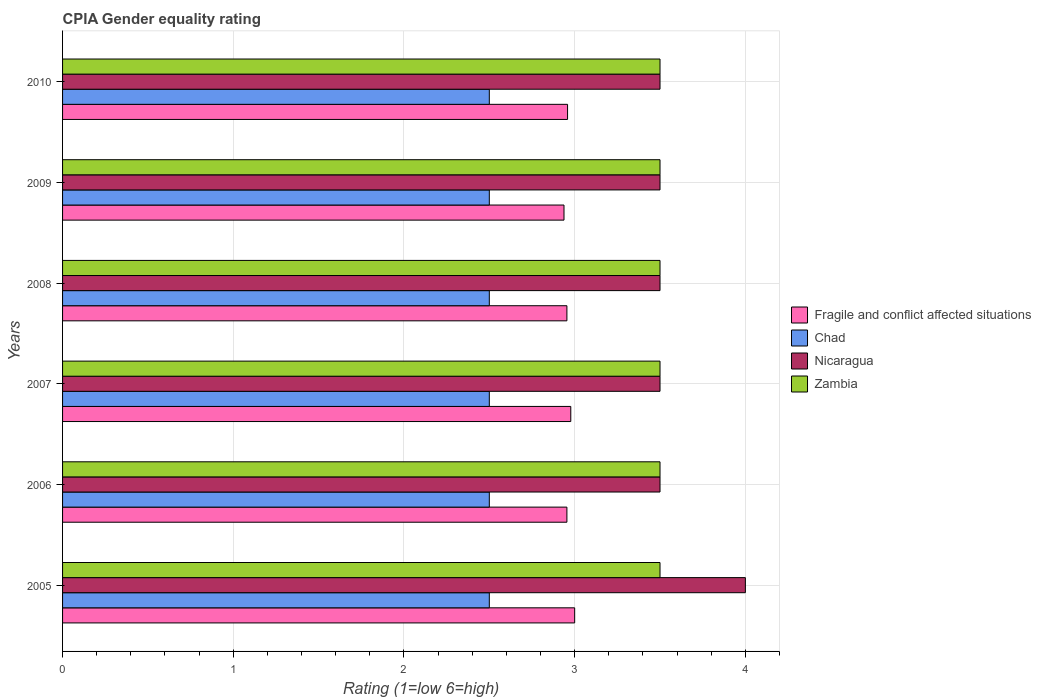Are the number of bars per tick equal to the number of legend labels?
Ensure brevity in your answer.  Yes. How many bars are there on the 6th tick from the top?
Provide a succinct answer. 4. What is the CPIA rating in Chad in 2005?
Offer a terse response. 2.5. In which year was the CPIA rating in Chad maximum?
Offer a very short reply. 2005. In which year was the CPIA rating in Chad minimum?
Give a very brief answer. 2005. What is the difference between the CPIA rating in Fragile and conflict affected situations in 2008 and that in 2009?
Provide a succinct answer. 0.02. What is the average CPIA rating in Nicaragua per year?
Give a very brief answer. 3.58. What is the ratio of the CPIA rating in Nicaragua in 2005 to that in 2008?
Your answer should be very brief. 1.14. Is the sum of the CPIA rating in Fragile and conflict affected situations in 2007 and 2008 greater than the maximum CPIA rating in Zambia across all years?
Ensure brevity in your answer.  Yes. What does the 3rd bar from the top in 2008 represents?
Provide a succinct answer. Chad. What does the 2nd bar from the bottom in 2010 represents?
Offer a terse response. Chad. Are all the bars in the graph horizontal?
Ensure brevity in your answer.  Yes. How many years are there in the graph?
Provide a succinct answer. 6. Does the graph contain grids?
Make the answer very short. Yes. How many legend labels are there?
Keep it short and to the point. 4. What is the title of the graph?
Make the answer very short. CPIA Gender equality rating. What is the label or title of the X-axis?
Your response must be concise. Rating (1=low 6=high). What is the Rating (1=low 6=high) of Nicaragua in 2005?
Your answer should be compact. 4. What is the Rating (1=low 6=high) in Zambia in 2005?
Provide a succinct answer. 3.5. What is the Rating (1=low 6=high) of Fragile and conflict affected situations in 2006?
Your response must be concise. 2.95. What is the Rating (1=low 6=high) of Chad in 2006?
Provide a succinct answer. 2.5. What is the Rating (1=low 6=high) of Nicaragua in 2006?
Your response must be concise. 3.5. What is the Rating (1=low 6=high) in Zambia in 2006?
Your response must be concise. 3.5. What is the Rating (1=low 6=high) of Fragile and conflict affected situations in 2007?
Offer a terse response. 2.98. What is the Rating (1=low 6=high) in Chad in 2007?
Your response must be concise. 2.5. What is the Rating (1=low 6=high) of Zambia in 2007?
Give a very brief answer. 3.5. What is the Rating (1=low 6=high) of Fragile and conflict affected situations in 2008?
Keep it short and to the point. 2.95. What is the Rating (1=low 6=high) of Chad in 2008?
Make the answer very short. 2.5. What is the Rating (1=low 6=high) of Fragile and conflict affected situations in 2009?
Offer a very short reply. 2.94. What is the Rating (1=low 6=high) in Fragile and conflict affected situations in 2010?
Your answer should be very brief. 2.96. Across all years, what is the maximum Rating (1=low 6=high) of Zambia?
Offer a terse response. 3.5. Across all years, what is the minimum Rating (1=low 6=high) in Fragile and conflict affected situations?
Provide a succinct answer. 2.94. Across all years, what is the minimum Rating (1=low 6=high) of Chad?
Provide a short and direct response. 2.5. What is the total Rating (1=low 6=high) in Fragile and conflict affected situations in the graph?
Offer a terse response. 17.78. What is the total Rating (1=low 6=high) in Chad in the graph?
Offer a very short reply. 15. What is the total Rating (1=low 6=high) of Nicaragua in the graph?
Provide a succinct answer. 21.5. What is the total Rating (1=low 6=high) of Zambia in the graph?
Make the answer very short. 21. What is the difference between the Rating (1=low 6=high) of Fragile and conflict affected situations in 2005 and that in 2006?
Give a very brief answer. 0.05. What is the difference between the Rating (1=low 6=high) of Fragile and conflict affected situations in 2005 and that in 2007?
Provide a succinct answer. 0.02. What is the difference between the Rating (1=low 6=high) of Fragile and conflict affected situations in 2005 and that in 2008?
Make the answer very short. 0.05. What is the difference between the Rating (1=low 6=high) of Nicaragua in 2005 and that in 2008?
Offer a very short reply. 0.5. What is the difference between the Rating (1=low 6=high) of Fragile and conflict affected situations in 2005 and that in 2009?
Offer a very short reply. 0.06. What is the difference between the Rating (1=low 6=high) in Nicaragua in 2005 and that in 2009?
Ensure brevity in your answer.  0.5. What is the difference between the Rating (1=low 6=high) in Fragile and conflict affected situations in 2005 and that in 2010?
Make the answer very short. 0.04. What is the difference between the Rating (1=low 6=high) of Fragile and conflict affected situations in 2006 and that in 2007?
Offer a terse response. -0.02. What is the difference between the Rating (1=low 6=high) of Zambia in 2006 and that in 2007?
Give a very brief answer. 0. What is the difference between the Rating (1=low 6=high) in Fragile and conflict affected situations in 2006 and that in 2008?
Your answer should be compact. 0. What is the difference between the Rating (1=low 6=high) in Fragile and conflict affected situations in 2006 and that in 2009?
Ensure brevity in your answer.  0.02. What is the difference between the Rating (1=low 6=high) of Chad in 2006 and that in 2009?
Provide a succinct answer. 0. What is the difference between the Rating (1=low 6=high) of Nicaragua in 2006 and that in 2009?
Ensure brevity in your answer.  0. What is the difference between the Rating (1=low 6=high) in Zambia in 2006 and that in 2009?
Keep it short and to the point. 0. What is the difference between the Rating (1=low 6=high) in Fragile and conflict affected situations in 2006 and that in 2010?
Your answer should be very brief. -0. What is the difference between the Rating (1=low 6=high) of Chad in 2006 and that in 2010?
Provide a short and direct response. 0. What is the difference between the Rating (1=low 6=high) of Nicaragua in 2006 and that in 2010?
Provide a short and direct response. 0. What is the difference between the Rating (1=low 6=high) of Zambia in 2006 and that in 2010?
Give a very brief answer. 0. What is the difference between the Rating (1=low 6=high) of Fragile and conflict affected situations in 2007 and that in 2008?
Offer a terse response. 0.02. What is the difference between the Rating (1=low 6=high) in Nicaragua in 2007 and that in 2008?
Ensure brevity in your answer.  0. What is the difference between the Rating (1=low 6=high) in Fragile and conflict affected situations in 2007 and that in 2009?
Offer a terse response. 0.04. What is the difference between the Rating (1=low 6=high) in Chad in 2007 and that in 2009?
Ensure brevity in your answer.  0. What is the difference between the Rating (1=low 6=high) of Zambia in 2007 and that in 2009?
Keep it short and to the point. 0. What is the difference between the Rating (1=low 6=high) in Fragile and conflict affected situations in 2007 and that in 2010?
Your answer should be compact. 0.02. What is the difference between the Rating (1=low 6=high) in Nicaragua in 2007 and that in 2010?
Offer a terse response. 0. What is the difference between the Rating (1=low 6=high) of Zambia in 2007 and that in 2010?
Your answer should be very brief. 0. What is the difference between the Rating (1=low 6=high) in Fragile and conflict affected situations in 2008 and that in 2009?
Provide a succinct answer. 0.02. What is the difference between the Rating (1=low 6=high) of Chad in 2008 and that in 2009?
Your answer should be compact. 0. What is the difference between the Rating (1=low 6=high) in Fragile and conflict affected situations in 2008 and that in 2010?
Keep it short and to the point. -0. What is the difference between the Rating (1=low 6=high) of Fragile and conflict affected situations in 2009 and that in 2010?
Your response must be concise. -0.02. What is the difference between the Rating (1=low 6=high) in Nicaragua in 2009 and that in 2010?
Your response must be concise. 0. What is the difference between the Rating (1=low 6=high) in Fragile and conflict affected situations in 2005 and the Rating (1=low 6=high) in Nicaragua in 2006?
Your response must be concise. -0.5. What is the difference between the Rating (1=low 6=high) of Chad in 2005 and the Rating (1=low 6=high) of Nicaragua in 2006?
Offer a very short reply. -1. What is the difference between the Rating (1=low 6=high) of Chad in 2005 and the Rating (1=low 6=high) of Zambia in 2006?
Provide a succinct answer. -1. What is the difference between the Rating (1=low 6=high) of Nicaragua in 2005 and the Rating (1=low 6=high) of Zambia in 2006?
Your answer should be compact. 0.5. What is the difference between the Rating (1=low 6=high) in Chad in 2005 and the Rating (1=low 6=high) in Nicaragua in 2007?
Provide a short and direct response. -1. What is the difference between the Rating (1=low 6=high) in Nicaragua in 2005 and the Rating (1=low 6=high) in Zambia in 2007?
Offer a very short reply. 0.5. What is the difference between the Rating (1=low 6=high) in Fragile and conflict affected situations in 2005 and the Rating (1=low 6=high) in Chad in 2008?
Your answer should be compact. 0.5. What is the difference between the Rating (1=low 6=high) of Fragile and conflict affected situations in 2005 and the Rating (1=low 6=high) of Zambia in 2008?
Give a very brief answer. -0.5. What is the difference between the Rating (1=low 6=high) in Chad in 2005 and the Rating (1=low 6=high) in Nicaragua in 2008?
Offer a very short reply. -1. What is the difference between the Rating (1=low 6=high) in Nicaragua in 2005 and the Rating (1=low 6=high) in Zambia in 2008?
Your answer should be very brief. 0.5. What is the difference between the Rating (1=low 6=high) in Fragile and conflict affected situations in 2005 and the Rating (1=low 6=high) in Zambia in 2009?
Your answer should be very brief. -0.5. What is the difference between the Rating (1=low 6=high) in Chad in 2005 and the Rating (1=low 6=high) in Nicaragua in 2009?
Provide a short and direct response. -1. What is the difference between the Rating (1=low 6=high) in Fragile and conflict affected situations in 2005 and the Rating (1=low 6=high) in Nicaragua in 2010?
Make the answer very short. -0.5. What is the difference between the Rating (1=low 6=high) of Fragile and conflict affected situations in 2005 and the Rating (1=low 6=high) of Zambia in 2010?
Provide a succinct answer. -0.5. What is the difference between the Rating (1=low 6=high) in Chad in 2005 and the Rating (1=low 6=high) in Nicaragua in 2010?
Ensure brevity in your answer.  -1. What is the difference between the Rating (1=low 6=high) in Fragile and conflict affected situations in 2006 and the Rating (1=low 6=high) in Chad in 2007?
Make the answer very short. 0.45. What is the difference between the Rating (1=low 6=high) of Fragile and conflict affected situations in 2006 and the Rating (1=low 6=high) of Nicaragua in 2007?
Offer a very short reply. -0.55. What is the difference between the Rating (1=low 6=high) in Fragile and conflict affected situations in 2006 and the Rating (1=low 6=high) in Zambia in 2007?
Provide a succinct answer. -0.55. What is the difference between the Rating (1=low 6=high) in Fragile and conflict affected situations in 2006 and the Rating (1=low 6=high) in Chad in 2008?
Your answer should be compact. 0.45. What is the difference between the Rating (1=low 6=high) in Fragile and conflict affected situations in 2006 and the Rating (1=low 6=high) in Nicaragua in 2008?
Give a very brief answer. -0.55. What is the difference between the Rating (1=low 6=high) in Fragile and conflict affected situations in 2006 and the Rating (1=low 6=high) in Zambia in 2008?
Provide a short and direct response. -0.55. What is the difference between the Rating (1=low 6=high) in Chad in 2006 and the Rating (1=low 6=high) in Zambia in 2008?
Your answer should be compact. -1. What is the difference between the Rating (1=low 6=high) of Fragile and conflict affected situations in 2006 and the Rating (1=low 6=high) of Chad in 2009?
Make the answer very short. 0.45. What is the difference between the Rating (1=low 6=high) in Fragile and conflict affected situations in 2006 and the Rating (1=low 6=high) in Nicaragua in 2009?
Offer a very short reply. -0.55. What is the difference between the Rating (1=low 6=high) in Fragile and conflict affected situations in 2006 and the Rating (1=low 6=high) in Zambia in 2009?
Your answer should be very brief. -0.55. What is the difference between the Rating (1=low 6=high) of Nicaragua in 2006 and the Rating (1=low 6=high) of Zambia in 2009?
Provide a succinct answer. 0. What is the difference between the Rating (1=low 6=high) in Fragile and conflict affected situations in 2006 and the Rating (1=low 6=high) in Chad in 2010?
Your answer should be very brief. 0.45. What is the difference between the Rating (1=low 6=high) of Fragile and conflict affected situations in 2006 and the Rating (1=low 6=high) of Nicaragua in 2010?
Your answer should be very brief. -0.55. What is the difference between the Rating (1=low 6=high) of Fragile and conflict affected situations in 2006 and the Rating (1=low 6=high) of Zambia in 2010?
Provide a short and direct response. -0.55. What is the difference between the Rating (1=low 6=high) in Chad in 2006 and the Rating (1=low 6=high) in Nicaragua in 2010?
Your answer should be very brief. -1. What is the difference between the Rating (1=low 6=high) in Nicaragua in 2006 and the Rating (1=low 6=high) in Zambia in 2010?
Offer a very short reply. 0. What is the difference between the Rating (1=low 6=high) of Fragile and conflict affected situations in 2007 and the Rating (1=low 6=high) of Chad in 2008?
Offer a very short reply. 0.48. What is the difference between the Rating (1=low 6=high) of Fragile and conflict affected situations in 2007 and the Rating (1=low 6=high) of Nicaragua in 2008?
Your answer should be compact. -0.52. What is the difference between the Rating (1=low 6=high) in Fragile and conflict affected situations in 2007 and the Rating (1=low 6=high) in Zambia in 2008?
Offer a terse response. -0.52. What is the difference between the Rating (1=low 6=high) of Chad in 2007 and the Rating (1=low 6=high) of Nicaragua in 2008?
Provide a short and direct response. -1. What is the difference between the Rating (1=low 6=high) in Fragile and conflict affected situations in 2007 and the Rating (1=low 6=high) in Chad in 2009?
Your answer should be very brief. 0.48. What is the difference between the Rating (1=low 6=high) of Fragile and conflict affected situations in 2007 and the Rating (1=low 6=high) of Nicaragua in 2009?
Your answer should be very brief. -0.52. What is the difference between the Rating (1=low 6=high) of Fragile and conflict affected situations in 2007 and the Rating (1=low 6=high) of Zambia in 2009?
Offer a very short reply. -0.52. What is the difference between the Rating (1=low 6=high) in Chad in 2007 and the Rating (1=low 6=high) in Nicaragua in 2009?
Your response must be concise. -1. What is the difference between the Rating (1=low 6=high) of Fragile and conflict affected situations in 2007 and the Rating (1=low 6=high) of Chad in 2010?
Your answer should be very brief. 0.48. What is the difference between the Rating (1=low 6=high) in Fragile and conflict affected situations in 2007 and the Rating (1=low 6=high) in Nicaragua in 2010?
Provide a short and direct response. -0.52. What is the difference between the Rating (1=low 6=high) in Fragile and conflict affected situations in 2007 and the Rating (1=low 6=high) in Zambia in 2010?
Your answer should be compact. -0.52. What is the difference between the Rating (1=low 6=high) of Chad in 2007 and the Rating (1=low 6=high) of Nicaragua in 2010?
Your answer should be compact. -1. What is the difference between the Rating (1=low 6=high) of Chad in 2007 and the Rating (1=low 6=high) of Zambia in 2010?
Provide a succinct answer. -1. What is the difference between the Rating (1=low 6=high) of Nicaragua in 2007 and the Rating (1=low 6=high) of Zambia in 2010?
Your answer should be very brief. 0. What is the difference between the Rating (1=low 6=high) in Fragile and conflict affected situations in 2008 and the Rating (1=low 6=high) in Chad in 2009?
Provide a short and direct response. 0.45. What is the difference between the Rating (1=low 6=high) in Fragile and conflict affected situations in 2008 and the Rating (1=low 6=high) in Nicaragua in 2009?
Ensure brevity in your answer.  -0.55. What is the difference between the Rating (1=low 6=high) of Fragile and conflict affected situations in 2008 and the Rating (1=low 6=high) of Zambia in 2009?
Make the answer very short. -0.55. What is the difference between the Rating (1=low 6=high) in Chad in 2008 and the Rating (1=low 6=high) in Zambia in 2009?
Give a very brief answer. -1. What is the difference between the Rating (1=low 6=high) in Nicaragua in 2008 and the Rating (1=low 6=high) in Zambia in 2009?
Provide a succinct answer. 0. What is the difference between the Rating (1=low 6=high) in Fragile and conflict affected situations in 2008 and the Rating (1=low 6=high) in Chad in 2010?
Keep it short and to the point. 0.45. What is the difference between the Rating (1=low 6=high) in Fragile and conflict affected situations in 2008 and the Rating (1=low 6=high) in Nicaragua in 2010?
Offer a terse response. -0.55. What is the difference between the Rating (1=low 6=high) in Fragile and conflict affected situations in 2008 and the Rating (1=low 6=high) in Zambia in 2010?
Your answer should be compact. -0.55. What is the difference between the Rating (1=low 6=high) in Chad in 2008 and the Rating (1=low 6=high) in Nicaragua in 2010?
Keep it short and to the point. -1. What is the difference between the Rating (1=low 6=high) of Nicaragua in 2008 and the Rating (1=low 6=high) of Zambia in 2010?
Your answer should be very brief. 0. What is the difference between the Rating (1=low 6=high) of Fragile and conflict affected situations in 2009 and the Rating (1=low 6=high) of Chad in 2010?
Provide a short and direct response. 0.44. What is the difference between the Rating (1=low 6=high) in Fragile and conflict affected situations in 2009 and the Rating (1=low 6=high) in Nicaragua in 2010?
Offer a very short reply. -0.56. What is the difference between the Rating (1=low 6=high) in Fragile and conflict affected situations in 2009 and the Rating (1=low 6=high) in Zambia in 2010?
Offer a terse response. -0.56. What is the difference between the Rating (1=low 6=high) of Chad in 2009 and the Rating (1=low 6=high) of Nicaragua in 2010?
Your answer should be compact. -1. What is the difference between the Rating (1=low 6=high) in Chad in 2009 and the Rating (1=low 6=high) in Zambia in 2010?
Give a very brief answer. -1. What is the average Rating (1=low 6=high) of Fragile and conflict affected situations per year?
Offer a very short reply. 2.96. What is the average Rating (1=low 6=high) in Chad per year?
Your answer should be compact. 2.5. What is the average Rating (1=low 6=high) in Nicaragua per year?
Provide a short and direct response. 3.58. In the year 2005, what is the difference between the Rating (1=low 6=high) of Fragile and conflict affected situations and Rating (1=low 6=high) of Chad?
Ensure brevity in your answer.  0.5. In the year 2005, what is the difference between the Rating (1=low 6=high) in Nicaragua and Rating (1=low 6=high) in Zambia?
Provide a short and direct response. 0.5. In the year 2006, what is the difference between the Rating (1=low 6=high) of Fragile and conflict affected situations and Rating (1=low 6=high) of Chad?
Offer a terse response. 0.45. In the year 2006, what is the difference between the Rating (1=low 6=high) in Fragile and conflict affected situations and Rating (1=low 6=high) in Nicaragua?
Make the answer very short. -0.55. In the year 2006, what is the difference between the Rating (1=low 6=high) in Fragile and conflict affected situations and Rating (1=low 6=high) in Zambia?
Your response must be concise. -0.55. In the year 2006, what is the difference between the Rating (1=low 6=high) in Chad and Rating (1=low 6=high) in Zambia?
Your response must be concise. -1. In the year 2006, what is the difference between the Rating (1=low 6=high) of Nicaragua and Rating (1=low 6=high) of Zambia?
Offer a terse response. 0. In the year 2007, what is the difference between the Rating (1=low 6=high) of Fragile and conflict affected situations and Rating (1=low 6=high) of Chad?
Ensure brevity in your answer.  0.48. In the year 2007, what is the difference between the Rating (1=low 6=high) of Fragile and conflict affected situations and Rating (1=low 6=high) of Nicaragua?
Offer a terse response. -0.52. In the year 2007, what is the difference between the Rating (1=low 6=high) in Fragile and conflict affected situations and Rating (1=low 6=high) in Zambia?
Provide a short and direct response. -0.52. In the year 2007, what is the difference between the Rating (1=low 6=high) in Chad and Rating (1=low 6=high) in Nicaragua?
Ensure brevity in your answer.  -1. In the year 2007, what is the difference between the Rating (1=low 6=high) in Chad and Rating (1=low 6=high) in Zambia?
Offer a very short reply. -1. In the year 2007, what is the difference between the Rating (1=low 6=high) in Nicaragua and Rating (1=low 6=high) in Zambia?
Keep it short and to the point. 0. In the year 2008, what is the difference between the Rating (1=low 6=high) of Fragile and conflict affected situations and Rating (1=low 6=high) of Chad?
Provide a short and direct response. 0.45. In the year 2008, what is the difference between the Rating (1=low 6=high) in Fragile and conflict affected situations and Rating (1=low 6=high) in Nicaragua?
Keep it short and to the point. -0.55. In the year 2008, what is the difference between the Rating (1=low 6=high) of Fragile and conflict affected situations and Rating (1=low 6=high) of Zambia?
Provide a short and direct response. -0.55. In the year 2008, what is the difference between the Rating (1=low 6=high) of Chad and Rating (1=low 6=high) of Nicaragua?
Offer a very short reply. -1. In the year 2008, what is the difference between the Rating (1=low 6=high) of Chad and Rating (1=low 6=high) of Zambia?
Make the answer very short. -1. In the year 2008, what is the difference between the Rating (1=low 6=high) of Nicaragua and Rating (1=low 6=high) of Zambia?
Offer a terse response. 0. In the year 2009, what is the difference between the Rating (1=low 6=high) in Fragile and conflict affected situations and Rating (1=low 6=high) in Chad?
Your answer should be compact. 0.44. In the year 2009, what is the difference between the Rating (1=low 6=high) of Fragile and conflict affected situations and Rating (1=low 6=high) of Nicaragua?
Offer a terse response. -0.56. In the year 2009, what is the difference between the Rating (1=low 6=high) in Fragile and conflict affected situations and Rating (1=low 6=high) in Zambia?
Your answer should be compact. -0.56. In the year 2009, what is the difference between the Rating (1=low 6=high) of Chad and Rating (1=low 6=high) of Nicaragua?
Give a very brief answer. -1. In the year 2009, what is the difference between the Rating (1=low 6=high) of Chad and Rating (1=low 6=high) of Zambia?
Offer a very short reply. -1. In the year 2009, what is the difference between the Rating (1=low 6=high) in Nicaragua and Rating (1=low 6=high) in Zambia?
Ensure brevity in your answer.  0. In the year 2010, what is the difference between the Rating (1=low 6=high) of Fragile and conflict affected situations and Rating (1=low 6=high) of Chad?
Keep it short and to the point. 0.46. In the year 2010, what is the difference between the Rating (1=low 6=high) in Fragile and conflict affected situations and Rating (1=low 6=high) in Nicaragua?
Your answer should be compact. -0.54. In the year 2010, what is the difference between the Rating (1=low 6=high) of Fragile and conflict affected situations and Rating (1=low 6=high) of Zambia?
Provide a short and direct response. -0.54. In the year 2010, what is the difference between the Rating (1=low 6=high) in Chad and Rating (1=low 6=high) in Zambia?
Your response must be concise. -1. In the year 2010, what is the difference between the Rating (1=low 6=high) in Nicaragua and Rating (1=low 6=high) in Zambia?
Keep it short and to the point. 0. What is the ratio of the Rating (1=low 6=high) of Fragile and conflict affected situations in 2005 to that in 2006?
Give a very brief answer. 1.02. What is the ratio of the Rating (1=low 6=high) in Zambia in 2005 to that in 2006?
Ensure brevity in your answer.  1. What is the ratio of the Rating (1=low 6=high) in Fragile and conflict affected situations in 2005 to that in 2007?
Ensure brevity in your answer.  1.01. What is the ratio of the Rating (1=low 6=high) in Chad in 2005 to that in 2007?
Offer a very short reply. 1. What is the ratio of the Rating (1=low 6=high) of Nicaragua in 2005 to that in 2007?
Make the answer very short. 1.14. What is the ratio of the Rating (1=low 6=high) in Fragile and conflict affected situations in 2005 to that in 2008?
Make the answer very short. 1.02. What is the ratio of the Rating (1=low 6=high) of Chad in 2005 to that in 2008?
Provide a succinct answer. 1. What is the ratio of the Rating (1=low 6=high) of Zambia in 2005 to that in 2008?
Ensure brevity in your answer.  1. What is the ratio of the Rating (1=low 6=high) of Fragile and conflict affected situations in 2005 to that in 2009?
Keep it short and to the point. 1.02. What is the ratio of the Rating (1=low 6=high) of Zambia in 2005 to that in 2009?
Your response must be concise. 1. What is the ratio of the Rating (1=low 6=high) in Fragile and conflict affected situations in 2005 to that in 2010?
Make the answer very short. 1.01. What is the ratio of the Rating (1=low 6=high) of Chad in 2005 to that in 2010?
Provide a short and direct response. 1. What is the ratio of the Rating (1=low 6=high) of Nicaragua in 2005 to that in 2010?
Your answer should be compact. 1.14. What is the ratio of the Rating (1=low 6=high) in Nicaragua in 2006 to that in 2007?
Offer a very short reply. 1. What is the ratio of the Rating (1=low 6=high) of Nicaragua in 2006 to that in 2008?
Provide a short and direct response. 1. What is the ratio of the Rating (1=low 6=high) of Zambia in 2006 to that in 2008?
Make the answer very short. 1. What is the ratio of the Rating (1=low 6=high) in Fragile and conflict affected situations in 2006 to that in 2009?
Ensure brevity in your answer.  1.01. What is the ratio of the Rating (1=low 6=high) of Fragile and conflict affected situations in 2006 to that in 2010?
Keep it short and to the point. 1. What is the ratio of the Rating (1=low 6=high) of Nicaragua in 2006 to that in 2010?
Keep it short and to the point. 1. What is the ratio of the Rating (1=low 6=high) of Fragile and conflict affected situations in 2007 to that in 2008?
Your response must be concise. 1.01. What is the ratio of the Rating (1=low 6=high) of Zambia in 2007 to that in 2008?
Provide a short and direct response. 1. What is the ratio of the Rating (1=low 6=high) in Fragile and conflict affected situations in 2007 to that in 2009?
Your response must be concise. 1.01. What is the ratio of the Rating (1=low 6=high) of Chad in 2007 to that in 2009?
Keep it short and to the point. 1. What is the ratio of the Rating (1=low 6=high) in Nicaragua in 2007 to that in 2009?
Your answer should be compact. 1. What is the ratio of the Rating (1=low 6=high) of Zambia in 2007 to that in 2009?
Your answer should be very brief. 1. What is the ratio of the Rating (1=low 6=high) in Fragile and conflict affected situations in 2007 to that in 2010?
Offer a terse response. 1.01. What is the ratio of the Rating (1=low 6=high) in Chad in 2007 to that in 2010?
Make the answer very short. 1. What is the ratio of the Rating (1=low 6=high) of Nicaragua in 2007 to that in 2010?
Provide a short and direct response. 1. What is the ratio of the Rating (1=low 6=high) of Chad in 2008 to that in 2009?
Make the answer very short. 1. What is the ratio of the Rating (1=low 6=high) in Nicaragua in 2008 to that in 2009?
Provide a short and direct response. 1. What is the ratio of the Rating (1=low 6=high) in Chad in 2008 to that in 2010?
Give a very brief answer. 1. What is the ratio of the Rating (1=low 6=high) in Zambia in 2008 to that in 2010?
Give a very brief answer. 1. What is the ratio of the Rating (1=low 6=high) of Fragile and conflict affected situations in 2009 to that in 2010?
Give a very brief answer. 0.99. What is the difference between the highest and the second highest Rating (1=low 6=high) of Fragile and conflict affected situations?
Your response must be concise. 0.02. What is the difference between the highest and the second highest Rating (1=low 6=high) in Chad?
Your response must be concise. 0. What is the difference between the highest and the second highest Rating (1=low 6=high) of Zambia?
Provide a short and direct response. 0. What is the difference between the highest and the lowest Rating (1=low 6=high) in Fragile and conflict affected situations?
Offer a very short reply. 0.06. What is the difference between the highest and the lowest Rating (1=low 6=high) in Chad?
Offer a terse response. 0. What is the difference between the highest and the lowest Rating (1=low 6=high) of Nicaragua?
Provide a succinct answer. 0.5. What is the difference between the highest and the lowest Rating (1=low 6=high) in Zambia?
Provide a succinct answer. 0. 